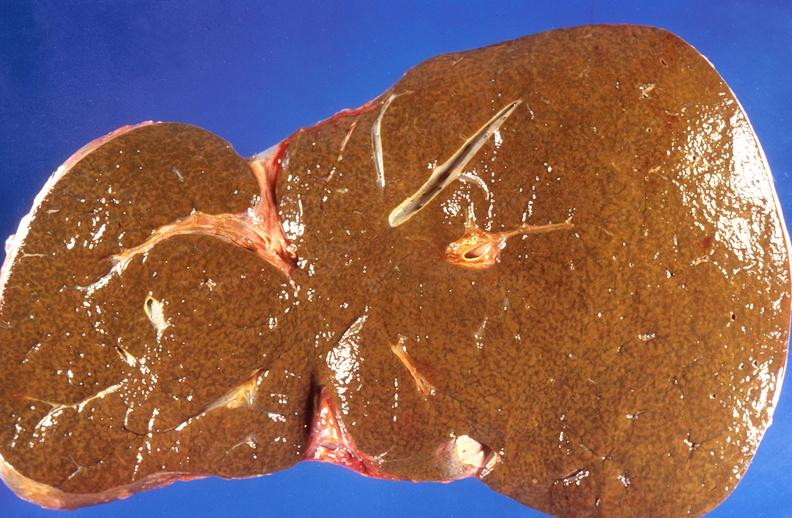what is present?
Answer the question using a single word or phrase. Hepatobiliary 